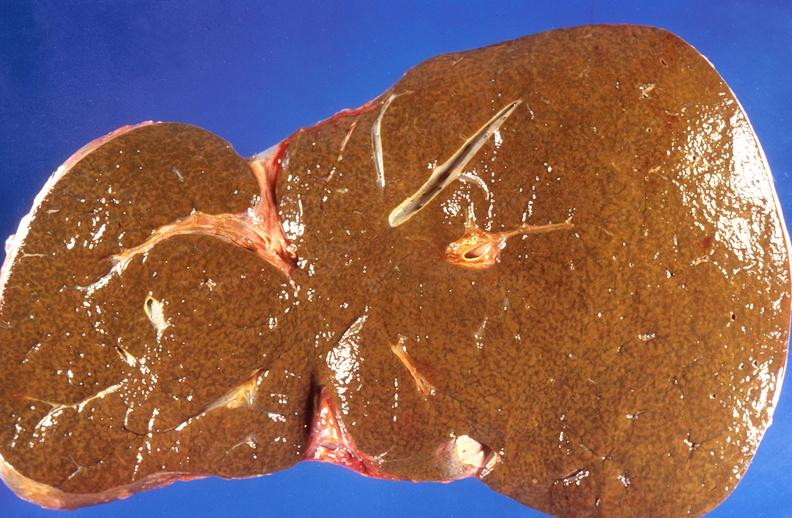what is present?
Answer the question using a single word or phrase. Hepatobiliary 